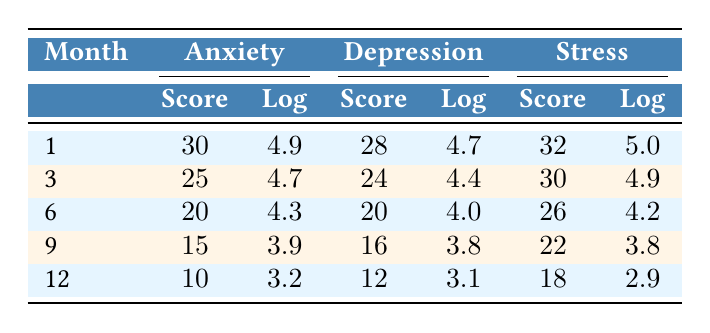What is the anxiety score in month 6? According to the table, the anxiety score listed for month 6 is 20.
Answer: 20 What is the depression score for month 1? The table indicates that the depression score for month 1 is 28.
Answer: 28 What was the lowest stress score recorded over the 12-month period? By examining the stress scores in the table, the lowest value is 18 in month 12.
Answer: 18 Calculate the average anxiety score for the months of 1 and 12. The anxiety scores for months 1 and 12 are 30 and 10, respectively. To find the average, sum these values (30 + 10) and divide by the number of months (2): (30 + 10) / 2 = 20.
Answer: 20 Is the log value of depression in month 3 greater than that of month 6? The log depression value for month 3 is 4.4 and for month 6 it is 4.0. Since 4.4 is greater than 4.0, the answer is yes.
Answer: Yes What is the total decrease in the anxiety score from month 1 to month 12? The anxiety score in month 1 is 30 and in month 12 is 10. The total decrease is calculated by subtracting the latter from the former: 30 - 10 = 20.
Answer: 20 Which month had the highest stress score, and what was it? Looking at the table, the highest stress score is 32 in month 1.
Answer: Month 1, 32 How does the depression score in month 9 compare to that in month 3? The depression score in month 9 is 16 while in month 3 it is 24. Since 16 is less than 24, the score in month 9 is lower.
Answer: Lower What is the change in log anxiety from month 1 to month 12? The log anxiety in month 1 is 4.9, and in month 12 it's 3.2. The change is calculated as 4.9 - 3.2 = 1.7.
Answer: 1.7 